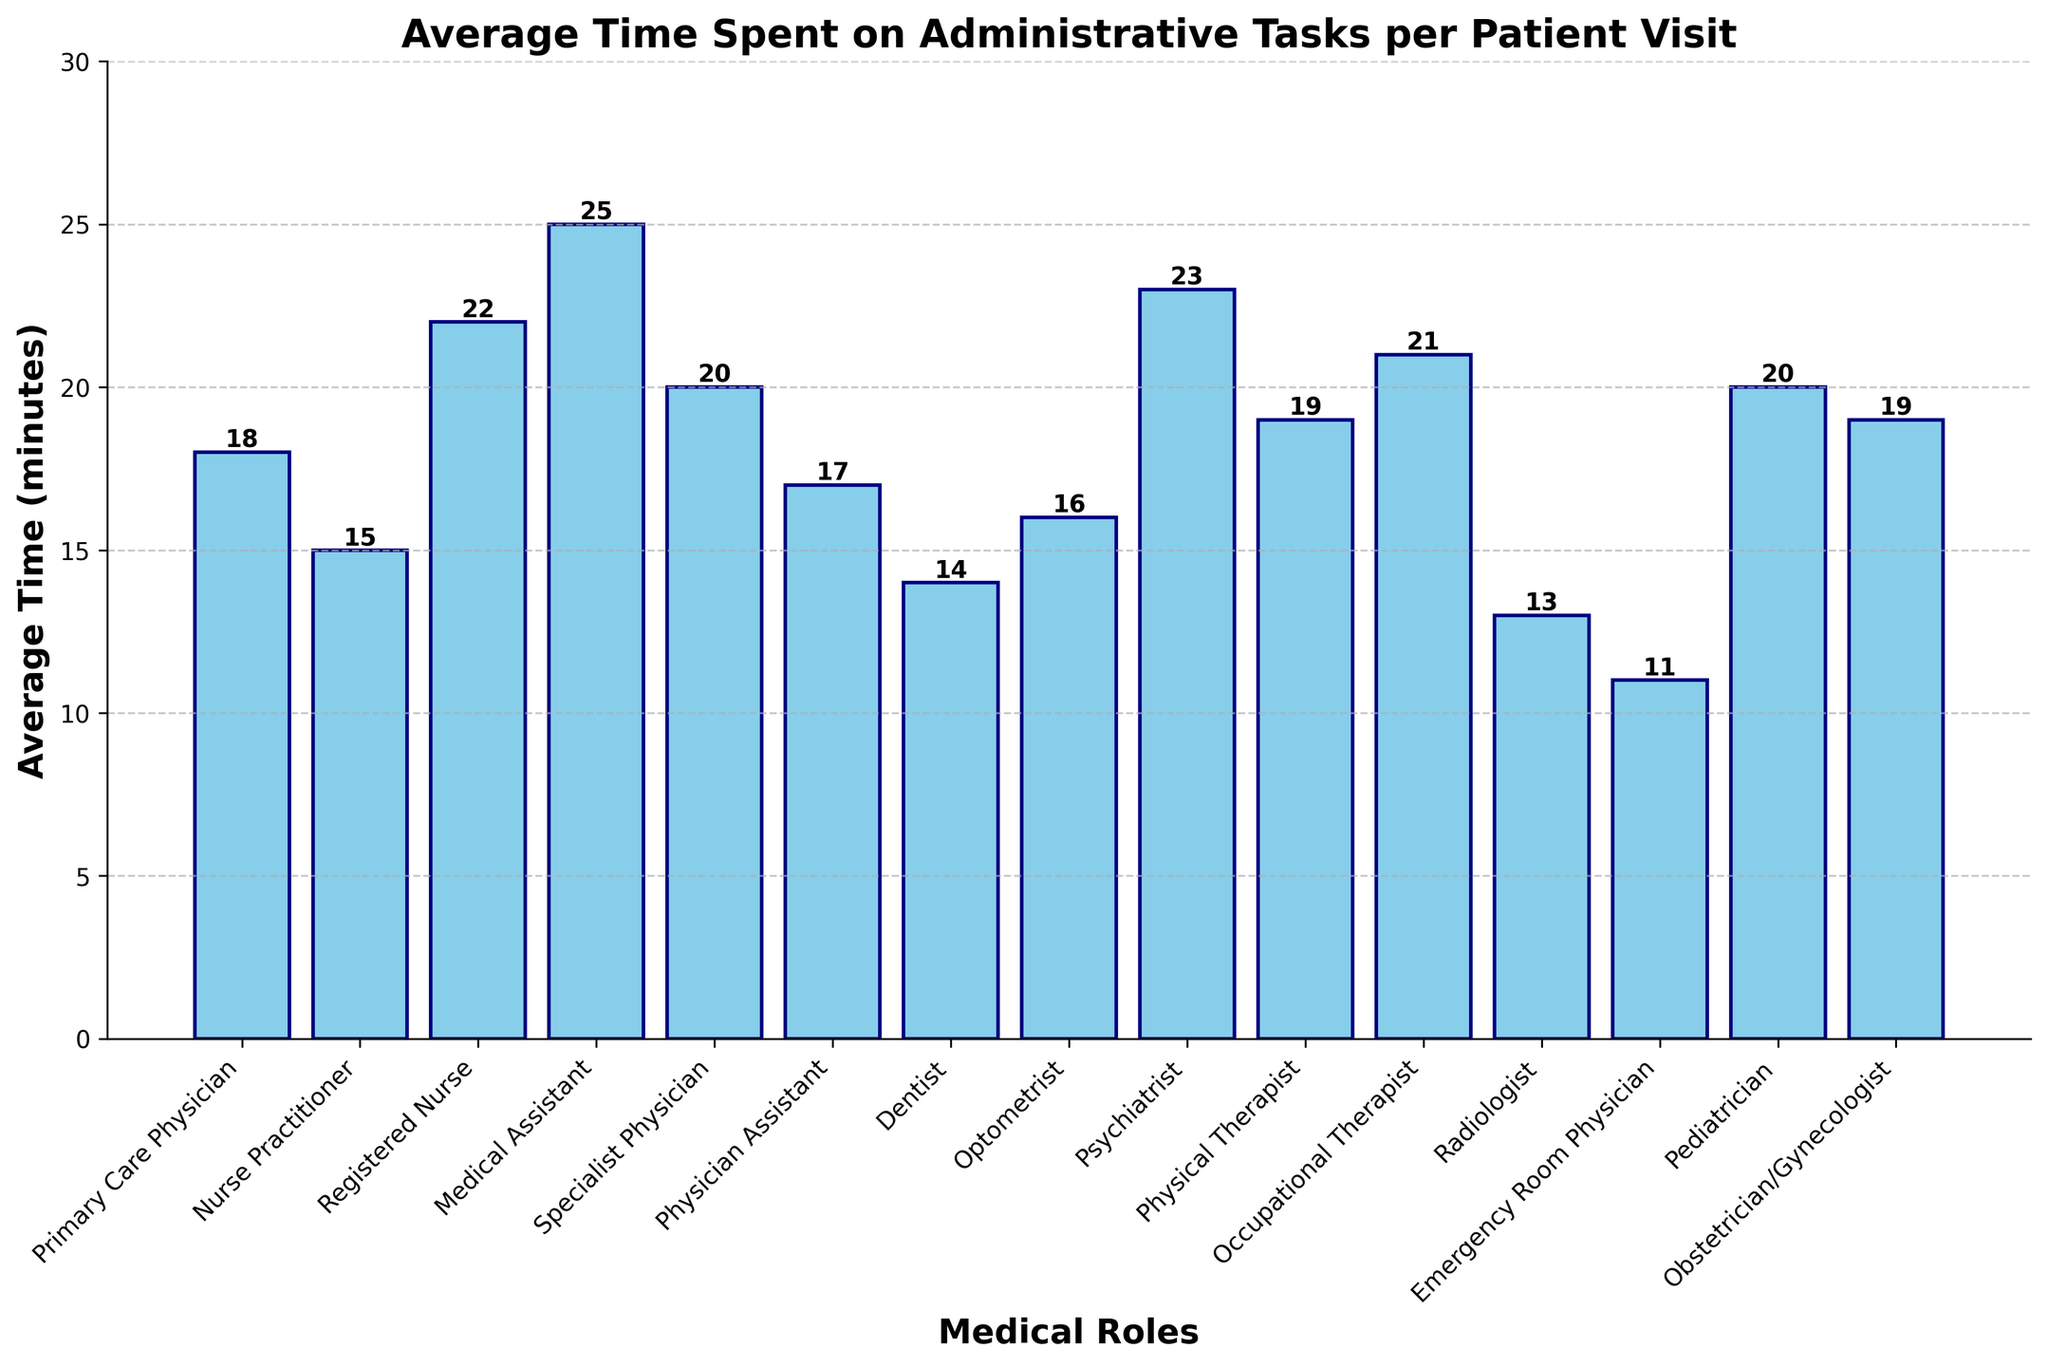Which medical role spends the most average time on administrative tasks per patient visit? The bar representing "Medical Assistant" is the tallest in the chart, which corresponds to 25 minutes.
Answer: Medical Assistant Which medical role spends the least average time on administrative tasks per patient visit? The bar representing "Emergency Room Physician" is the shortest in the chart, which corresponds to 11 minutes.
Answer: Emergency Room Physician How much more time does a Registered Nurse spend on administrative tasks per patient visit compared to an Optometrist? The bar for "Registered Nurse" shows 22 minutes, and the bar for "Optometrist" shows 16 minutes. The difference is 22 - 16 = 6 minutes.
Answer: 6 minutes What is the combined average time spent on administrative tasks per patient visit by a Primary Care Physician and a Specialist Physician? The bar for "Primary Care Physician" shows 18 minutes and the bar for "Specialist Physician" shows 20 minutes. The combined time is 18 + 20 = 38 minutes.
Answer: 38 minutes Is the average time spent on administrative tasks by a Pediatrician equal to, greater than, or less than that of a Psychiatrist? The bar for "Pediatrician" shows 20 minutes, and the bar for "Psychiatrist" shows 23 minutes. 20 is less than 23.
Answer: Less than Which two roles have the closest average time spent on administrative tasks per patient visit, and what are their times? The bars for "Dentist" and "Radiologist" are 14 minutes and 13 minutes respectively. The difference is 1 minute, which is the smallest difference among the roles listed.
Answer: Dentist and Radiologist, 14 and 13 minutes Compare the average time spent on administrative tasks by a Pediatrician and an Occupational Therapist. How much time is spent in total by both roles combined? The bar for "Pediatrician" shows 20 minutes and the bar for "Occupational Therapist" shows 21 minutes. The total time is 20 + 21 = 41 minutes.
Answer: 41 minutes How much more time does a Physical Therapist spend on administrative tasks per patient visit compared to a Dentist? The bar for "Physical Therapist" shows 19 minutes and the bar for "Dentist" shows 14 minutes. The difference is 19 - 14 = 5 minutes.
Answer: 5 minutes Which role has a median average time spent on administrative tasks per patient visit, and what is that time? To find the median, we list the times in ascending order: 11, 13, 14, 15, 16, 17, 18, 19, 19, 20, 20, 21, 22, 23, 25. The median value, being the 8th in the list, is for "Physical Therapist" which is 19 minutes.
Answer: Physical Therapist, 19 minutes 